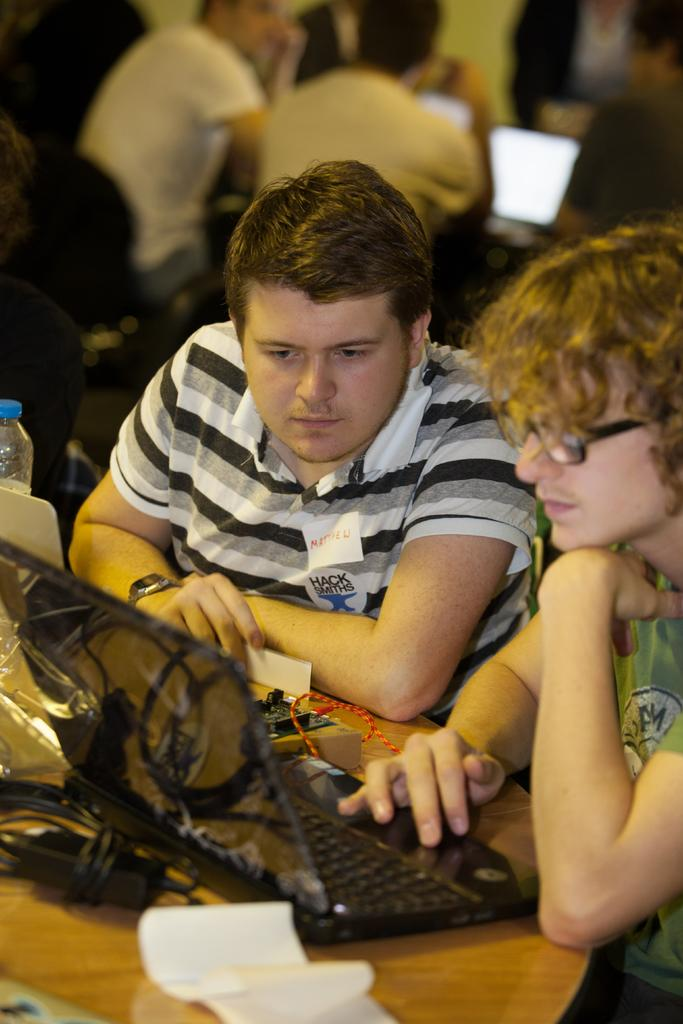What are the people in the image doing? The people in the image are sitting on chairs. What is present on the table in the image? There is a keyboard, a monitor, papers, and a water bottle on the table. What type of electronic device is on the table? There is a keyboard and a monitor on the table. How many rings can be seen on the people's fingers in the image? There is no information about rings on the people's fingers in the image. What time of day is depicted in the image? The time of day is not mentioned in the image, so it cannot be determined. 